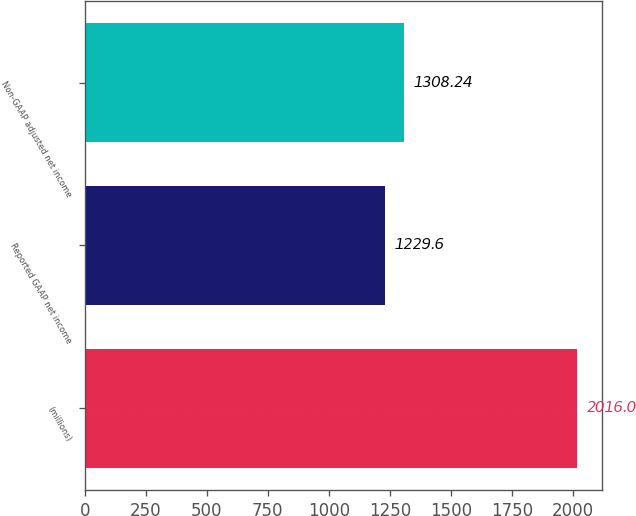Convert chart. <chart><loc_0><loc_0><loc_500><loc_500><bar_chart><fcel>(millions)<fcel>Reported GAAP net income<fcel>Non-GAAP adjusted net income<nl><fcel>2016<fcel>1229.6<fcel>1308.24<nl></chart> 